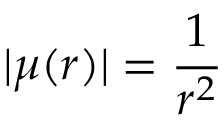<formula> <loc_0><loc_0><loc_500><loc_500>| \mu ( r ) | = \frac { 1 } { r ^ { 2 } }</formula> 